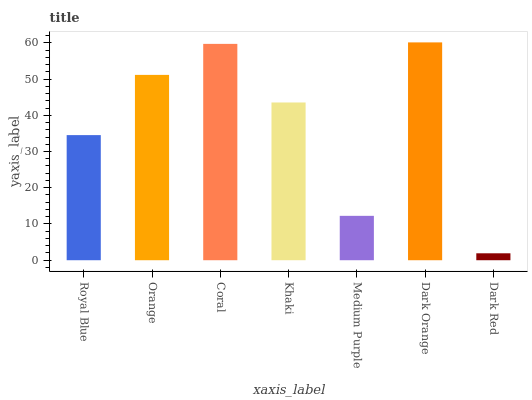Is Dark Red the minimum?
Answer yes or no. Yes. Is Dark Orange the maximum?
Answer yes or no. Yes. Is Orange the minimum?
Answer yes or no. No. Is Orange the maximum?
Answer yes or no. No. Is Orange greater than Royal Blue?
Answer yes or no. Yes. Is Royal Blue less than Orange?
Answer yes or no. Yes. Is Royal Blue greater than Orange?
Answer yes or no. No. Is Orange less than Royal Blue?
Answer yes or no. No. Is Khaki the high median?
Answer yes or no. Yes. Is Khaki the low median?
Answer yes or no. Yes. Is Coral the high median?
Answer yes or no. No. Is Dark Red the low median?
Answer yes or no. No. 